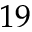Convert formula to latex. <formula><loc_0><loc_0><loc_500><loc_500>1 9</formula> 